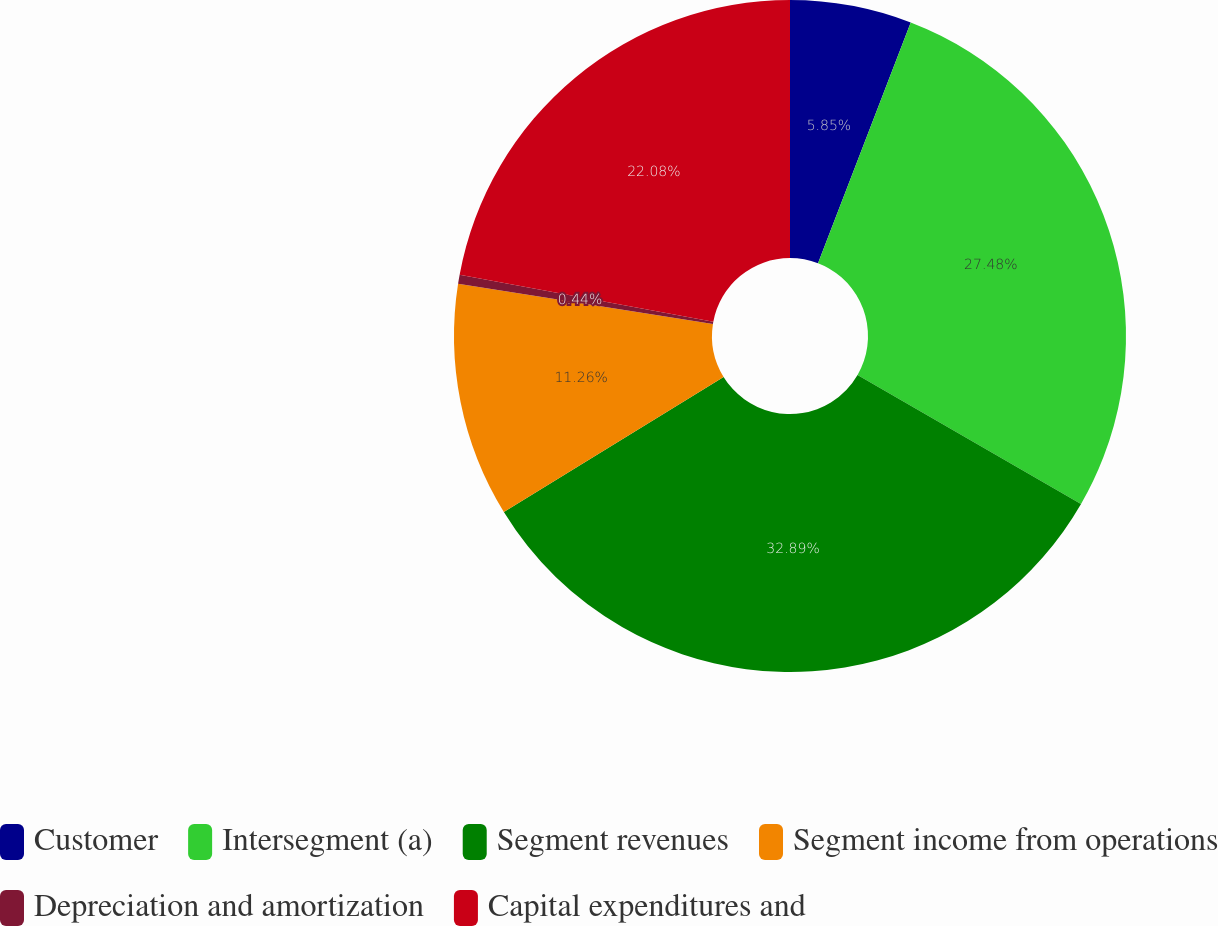<chart> <loc_0><loc_0><loc_500><loc_500><pie_chart><fcel>Customer<fcel>Intersegment (a)<fcel>Segment revenues<fcel>Segment income from operations<fcel>Depreciation and amortization<fcel>Capital expenditures and<nl><fcel>5.85%<fcel>27.48%<fcel>32.89%<fcel>11.26%<fcel>0.44%<fcel>22.08%<nl></chart> 